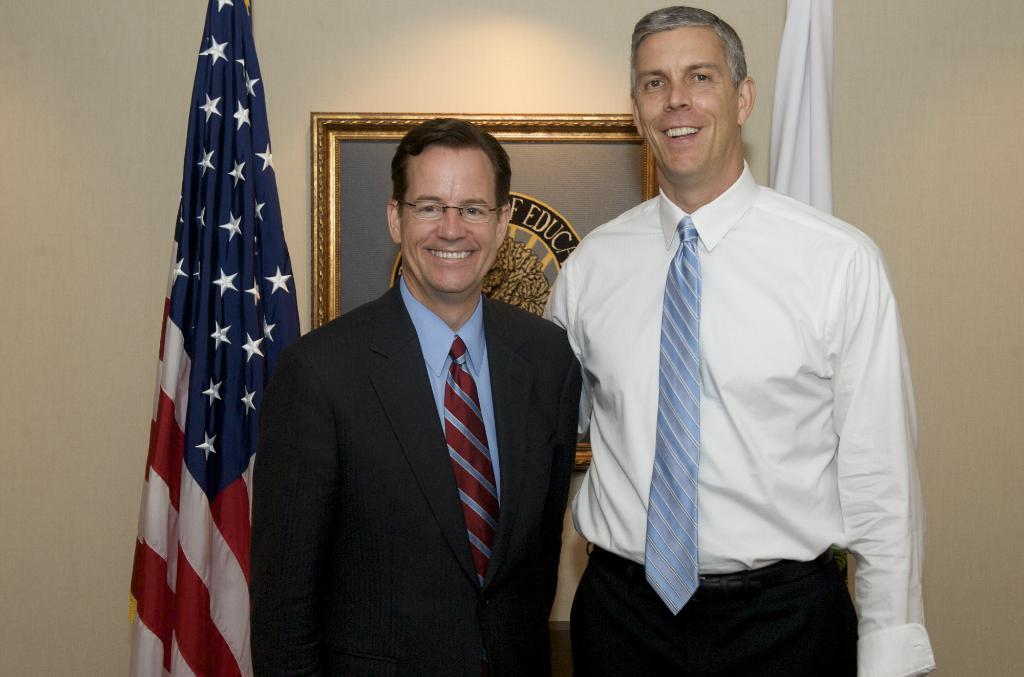How many people are in the image? There are two people in the image. What are the people doing in the image? The people are standing with smiles on their faces. What can be seen on the wall in the background? There is a frame hanging on the wall in the background. What else is visible in the background? There are two flags in the background. What type of pump is being used to generate steam in the image? There is no pump or steam present in the image; it features two people standing with smiles on their faces and a background with a frame and two flags. 